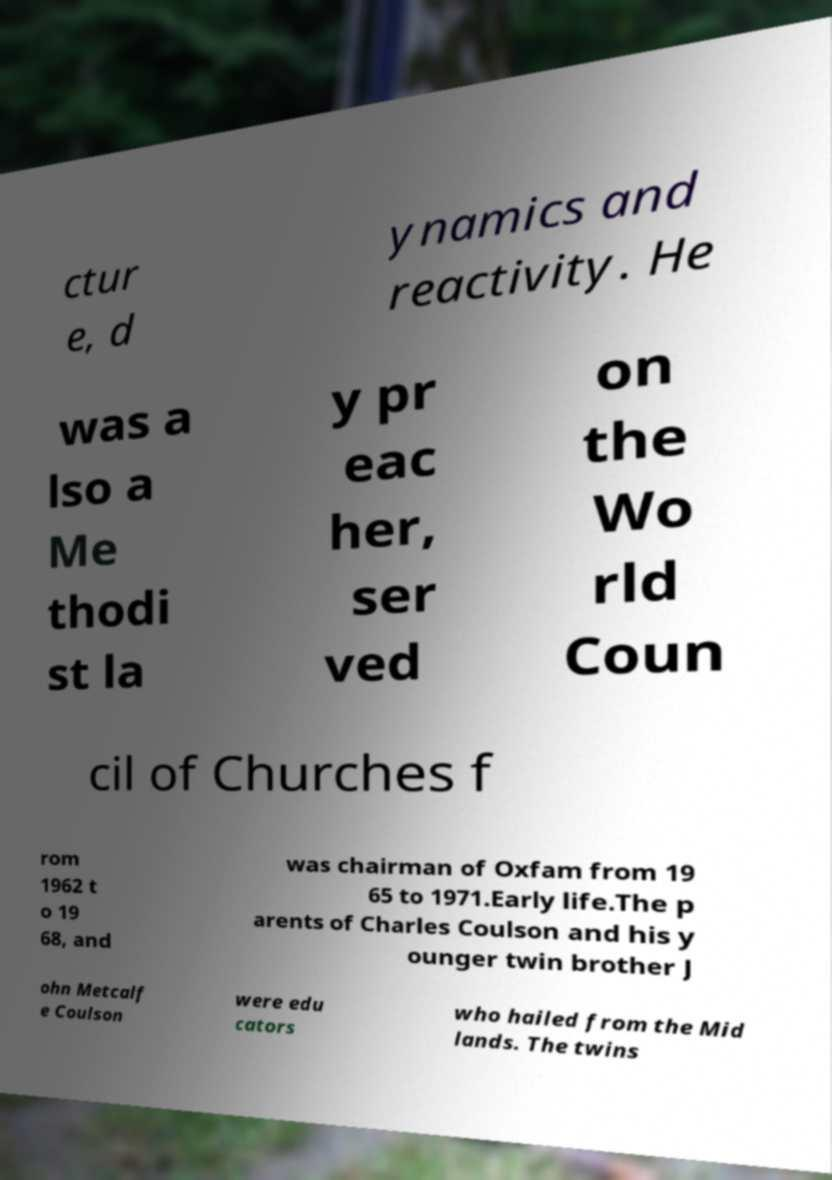Can you accurately transcribe the text from the provided image for me? ctur e, d ynamics and reactivity. He was a lso a Me thodi st la y pr eac her, ser ved on the Wo rld Coun cil of Churches f rom 1962 t o 19 68, and was chairman of Oxfam from 19 65 to 1971.Early life.The p arents of Charles Coulson and his y ounger twin brother J ohn Metcalf e Coulson were edu cators who hailed from the Mid lands. The twins 